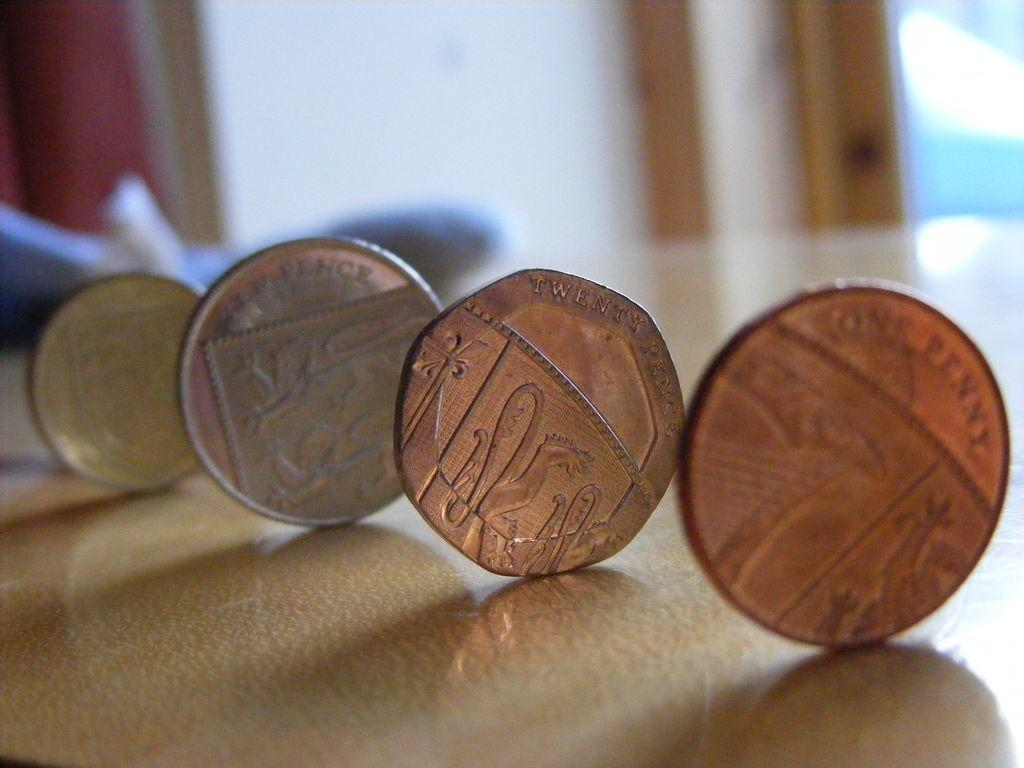<image>
Provide a brief description of the given image. several British coins, one of which has the word penny on it 